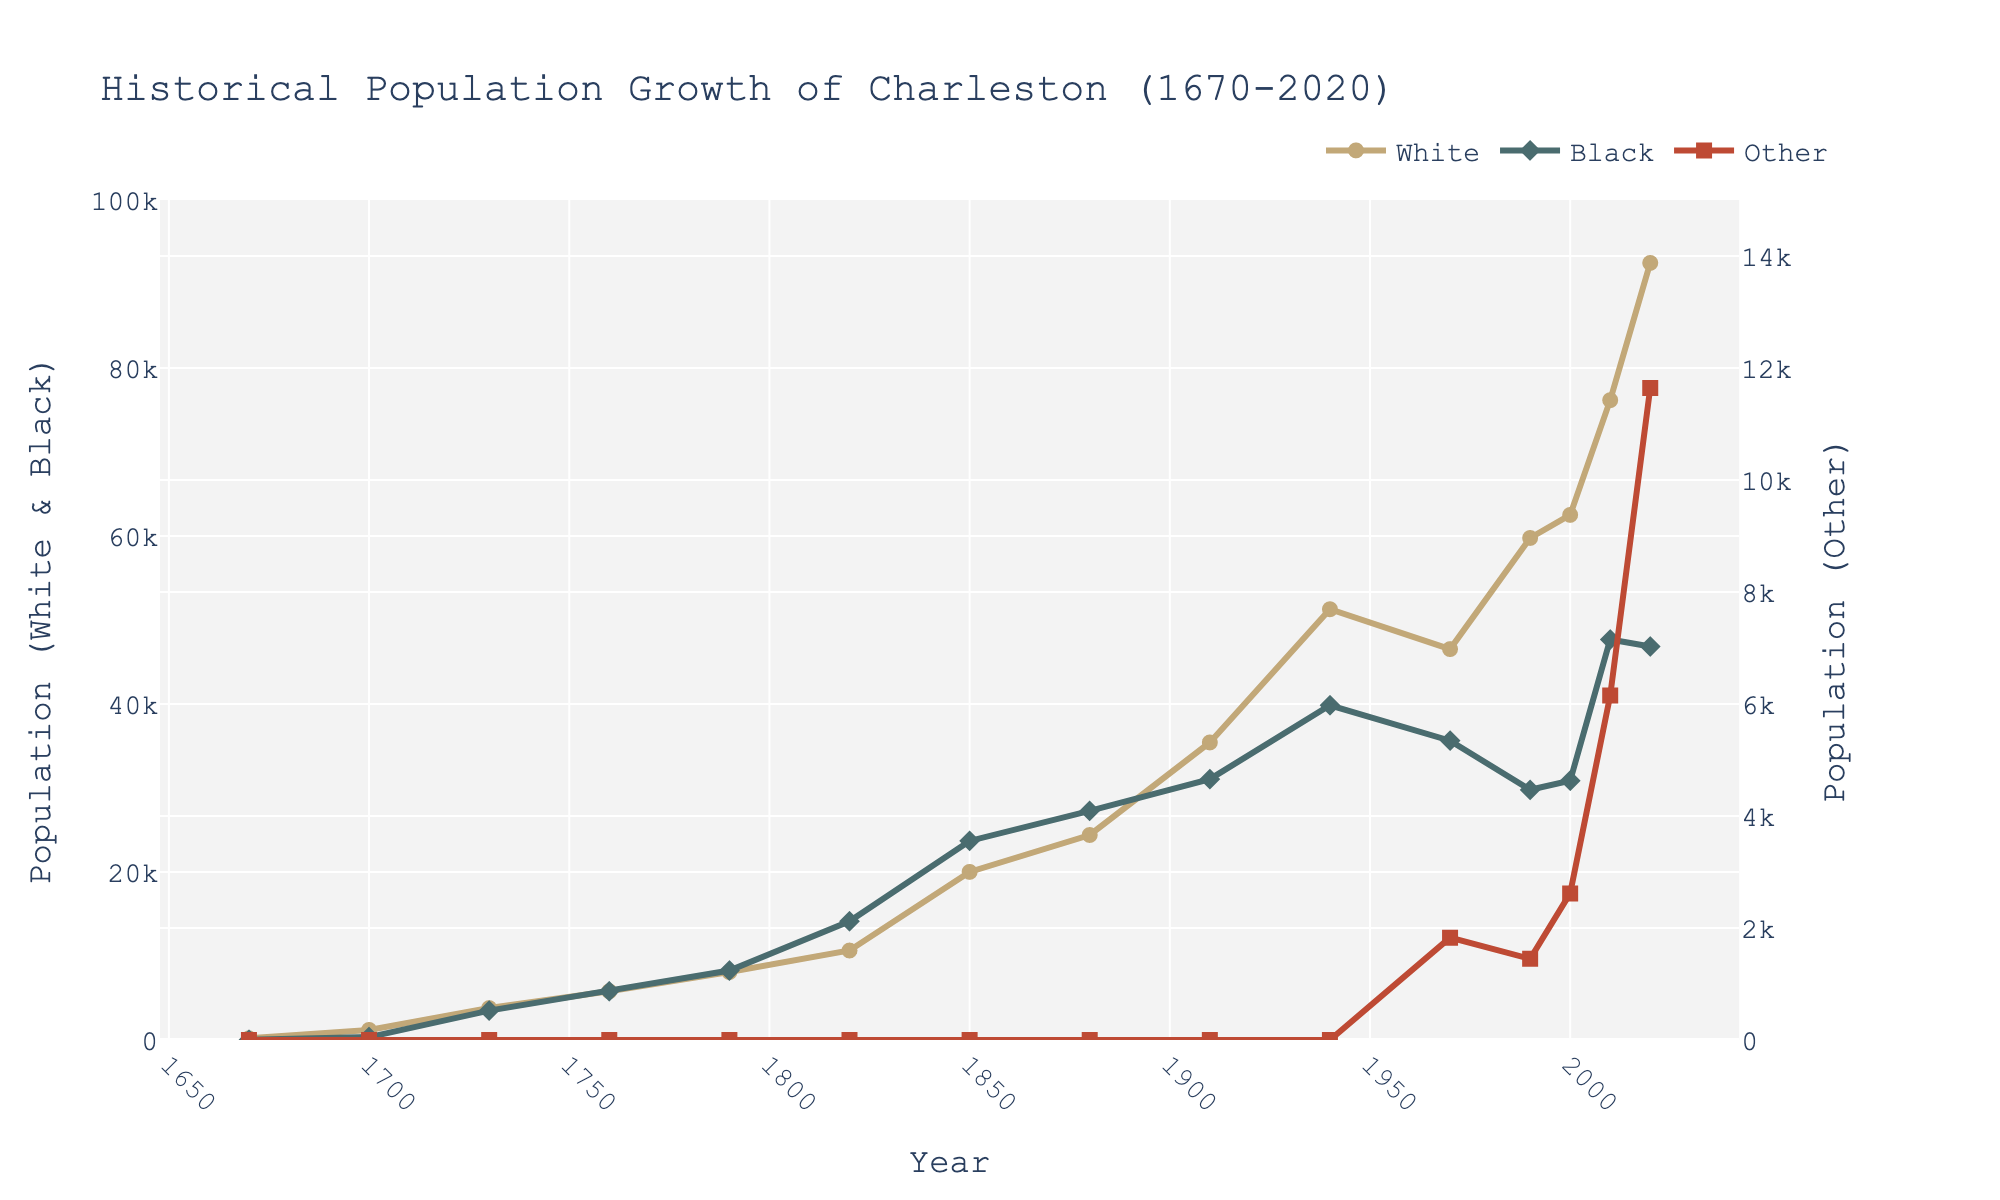What is the increase in the White population from 1670 to 1760? The White population in 1670 was 200 and in 1760 it was 5800. The increase is 5800 - 200 = 5600.
Answer: 5600 How does the Black population in 1760 compare to the White population in 1790? The Black population in 1760 was 5800 and the White population in 1790 was 8089. 5800 is less than 8089 by 2289.
Answer: Less by 2289 Which racial demographic showed the most significant increase between 1970 and 2020? The White population increased from 46536 to 92510, the Black population decreased from 35636 to 46845, and the Other population increased from 1828 to 11645. The White population shows the most significant increase: 92510 - 46536 = 45974.
Answer: White What was the combined population of Black and White demographics in 1820? The Black population in 1820 was 14127 and the White population was 10653. The combined population is 14127 + 10653 = 24780.
Answer: 24780 How did the Other population grow between 1990 and 2020? The Other population in 1990 was 1449 and in 2020 it was 11645. The increase is 11645 - 1449 = 10196.
Answer: 10196 In which decade did the White population surpass the Black population for the first time? The White population first surpassed the Black population between 1910 (White: 35424, Black: 31056) and 1940 (White: 51280, Black: 39851).
Answer: 1910-1940 Which racial demographic had the highest population in 1820? In 1820, the Black population was 14127 while the White population was 10653. The Black population was higher.
Answer: Black What was the relative growth of the White population from 2000 to 2020 as a percentage? The White population in 2000 was 62513, and in 2020 it was 92510. The growth is (92510 - 62513) / 62513 * 100% ≈ 47.97%.
Answer: ≈ 47.97% Which group had a steadier population growth from 1970 to 2020, White or Black? The White population grew from 46536 to 92510 relatively steadily. In contrast, the Black population saw a peak in 2010 but then decreased slightly by 2020. The White group had a steadier growth.
Answer: White 